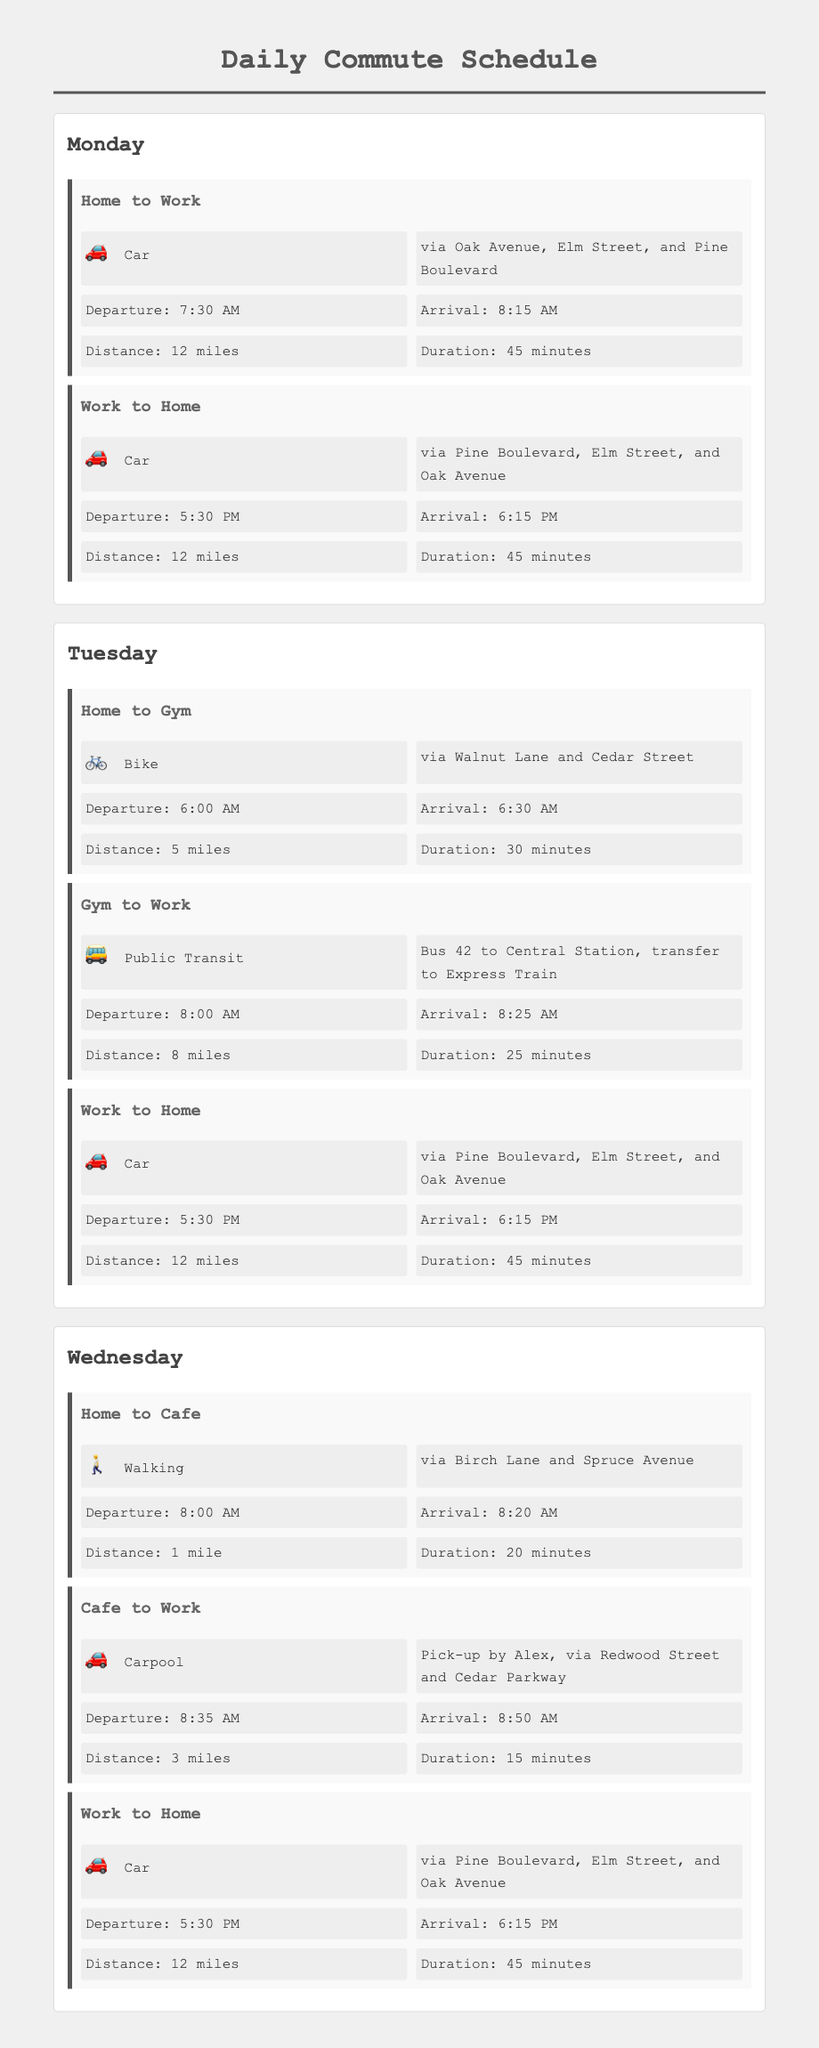What time does the Monday commute from Home to Work start? The departure time for Monday's commute from Home to Work is stated as 7:30 AM.
Answer: 7:30 AM How long does the Tuesday commute from Home to Gym take? The duration for the Tuesday commute from Home to Gym is given as 30 minutes.
Answer: 30 minutes What is the total distance for the Wednesday commute from Home to Cafe? The distance for the Wednesday commute from Home to Cafe is specified as 1 mile.
Answer: 1 mile What route is used for the commute from Work to Home on Monday? The route is via Pine Boulevard, Elm Street, and Oak Avenue as detailed in the document.
Answer: via Pine Boulevard, Elm Street, and Oak Avenue What mode of transport is used for the Tuesday commute from Gym to Work? The transport mode for this commute is Public Transit, specifically Bus 42.
Answer: Public Transit When does the commute from Home to Cafe start on Wednesday? The document states that the departure time from Home to Cafe on Wednesday is 8:00 AM.
Answer: 8:00 AM What is the distance for the Gym to Work commute on Tuesday? The distance for this commute is mentioned as 8 miles.
Answer: 8 miles On which day is the commute from Home to Work via car? The document describes this route on Monday, thus making Monday the relevant day.
Answer: Monday 